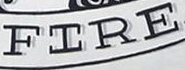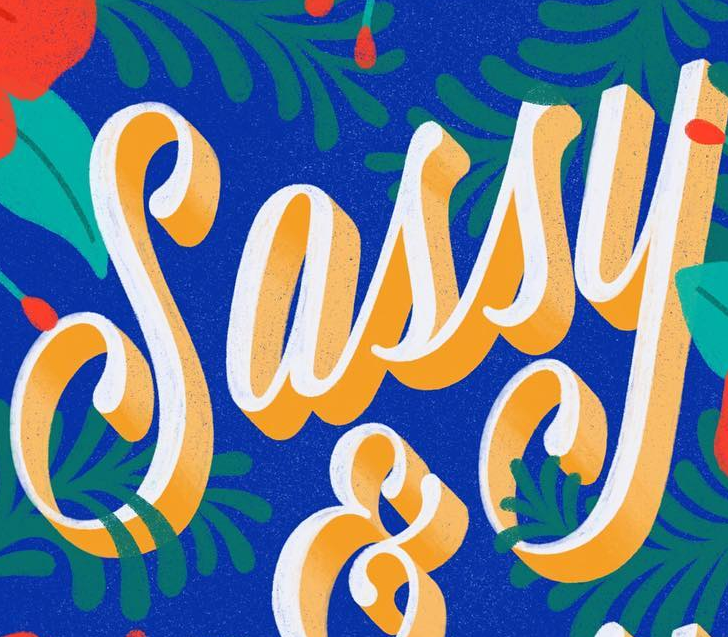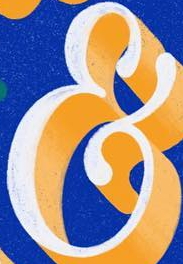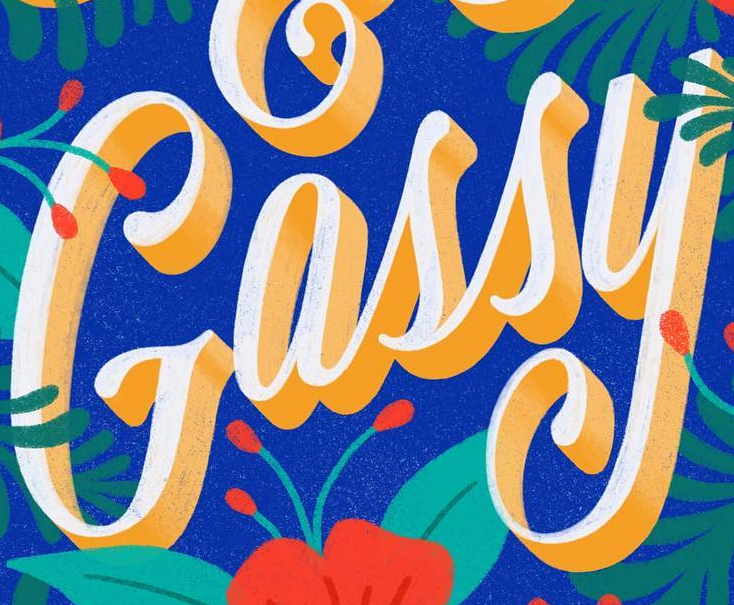Identify the words shown in these images in order, separated by a semicolon. FIRE; Sassy; &; Gassy 